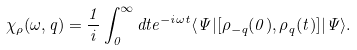Convert formula to latex. <formula><loc_0><loc_0><loc_500><loc_500>\chi _ { \rho } ( \omega , { q } ) = \frac { 1 } { i } \int _ { 0 } ^ { \infty } d t e ^ { - i \omega t } \langle \Psi | [ \rho _ { - { q } } ( 0 ) , \rho _ { q } ( t ) ] | \Psi \rangle .</formula> 